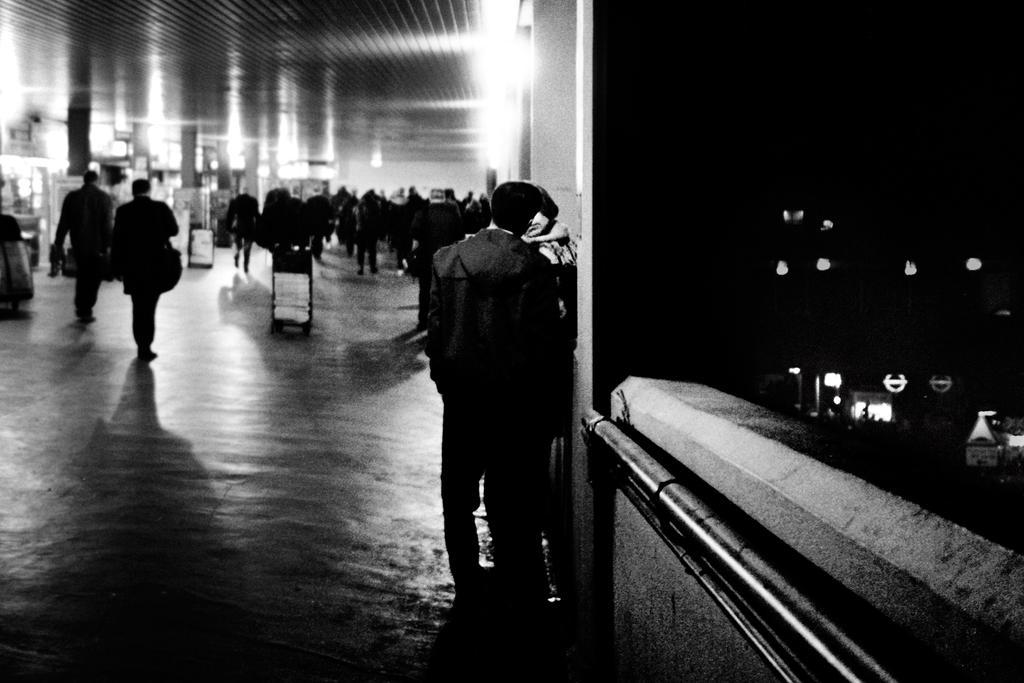Could you give a brief overview of what you see in this image? In this image there are few peoples visible on the floor there are some boats, pillars visible in the middle, on the right side there is a darkness there are some lights visible. 